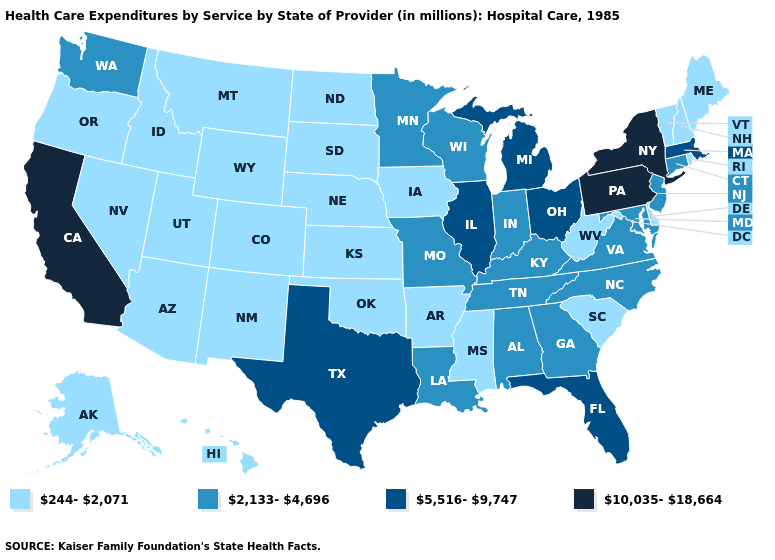Which states have the highest value in the USA?
Keep it brief. California, New York, Pennsylvania. Name the states that have a value in the range 5,516-9,747?
Give a very brief answer. Florida, Illinois, Massachusetts, Michigan, Ohio, Texas. What is the value of Texas?
Short answer required. 5,516-9,747. Name the states that have a value in the range 5,516-9,747?
Give a very brief answer. Florida, Illinois, Massachusetts, Michigan, Ohio, Texas. Does New Mexico have the same value as California?
Write a very short answer. No. Does California have the lowest value in the West?
Answer briefly. No. Which states hav the highest value in the South?
Answer briefly. Florida, Texas. Name the states that have a value in the range 5,516-9,747?
Be succinct. Florida, Illinois, Massachusetts, Michigan, Ohio, Texas. Does Utah have a lower value than Virginia?
Concise answer only. Yes. How many symbols are there in the legend?
Quick response, please. 4. Name the states that have a value in the range 244-2,071?
Write a very short answer. Alaska, Arizona, Arkansas, Colorado, Delaware, Hawaii, Idaho, Iowa, Kansas, Maine, Mississippi, Montana, Nebraska, Nevada, New Hampshire, New Mexico, North Dakota, Oklahoma, Oregon, Rhode Island, South Carolina, South Dakota, Utah, Vermont, West Virginia, Wyoming. What is the lowest value in states that border New Hampshire?
Concise answer only. 244-2,071. What is the lowest value in the MidWest?
Short answer required. 244-2,071. Which states have the highest value in the USA?
Answer briefly. California, New York, Pennsylvania. What is the highest value in the MidWest ?
Quick response, please. 5,516-9,747. 